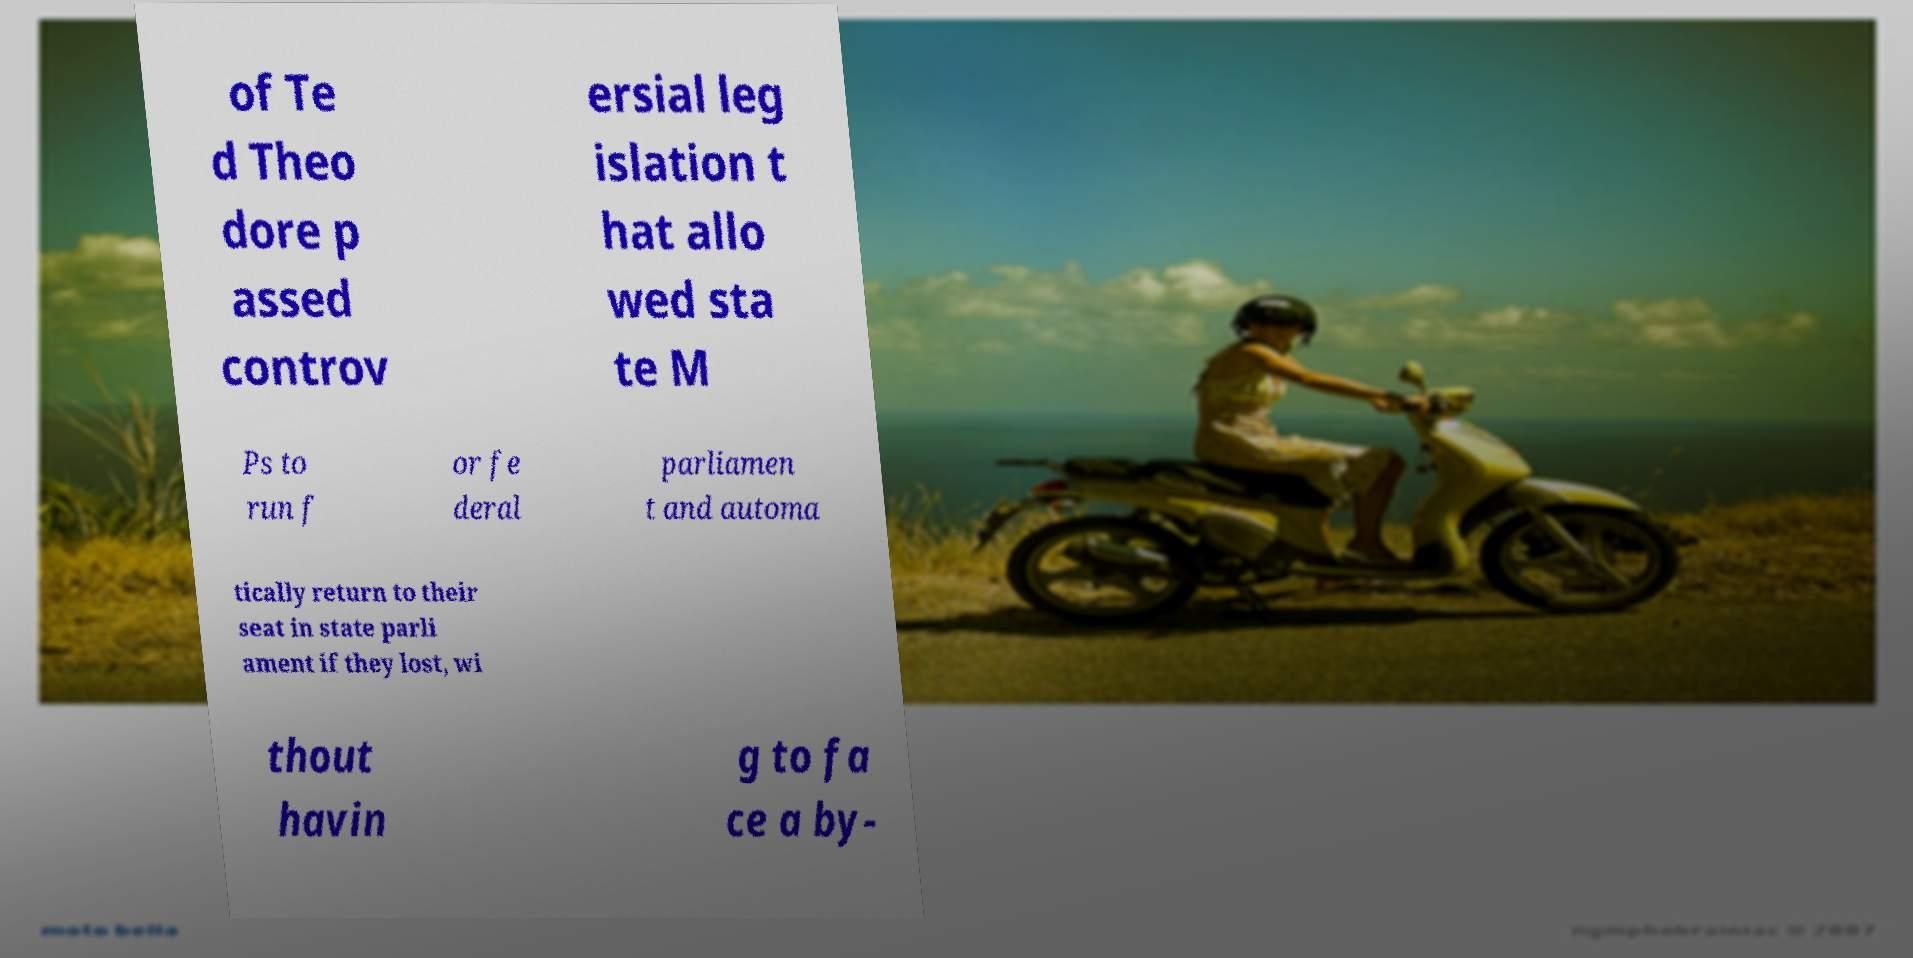Please identify and transcribe the text found in this image. of Te d Theo dore p assed controv ersial leg islation t hat allo wed sta te M Ps to run f or fe deral parliamen t and automa tically return to their seat in state parli ament if they lost, wi thout havin g to fa ce a by- 